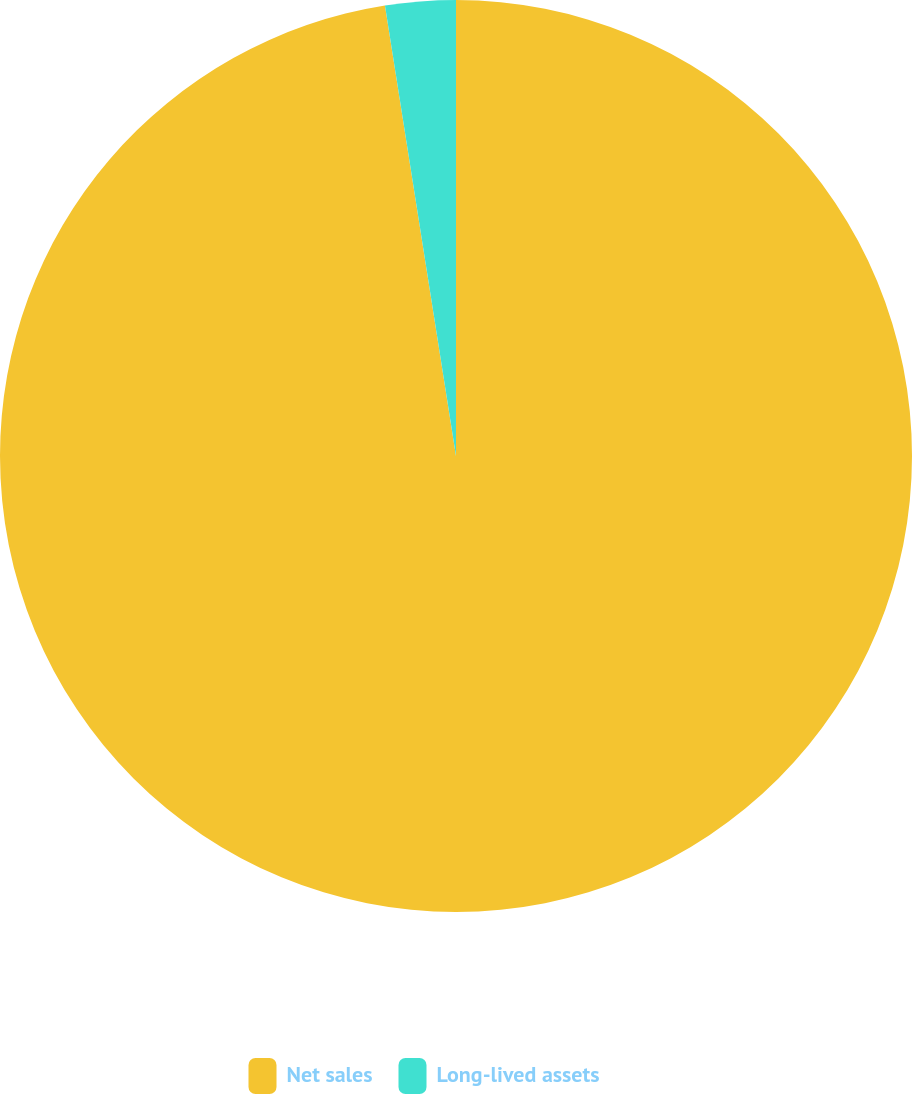<chart> <loc_0><loc_0><loc_500><loc_500><pie_chart><fcel>Net sales<fcel>Long-lived assets<nl><fcel>97.51%<fcel>2.49%<nl></chart> 